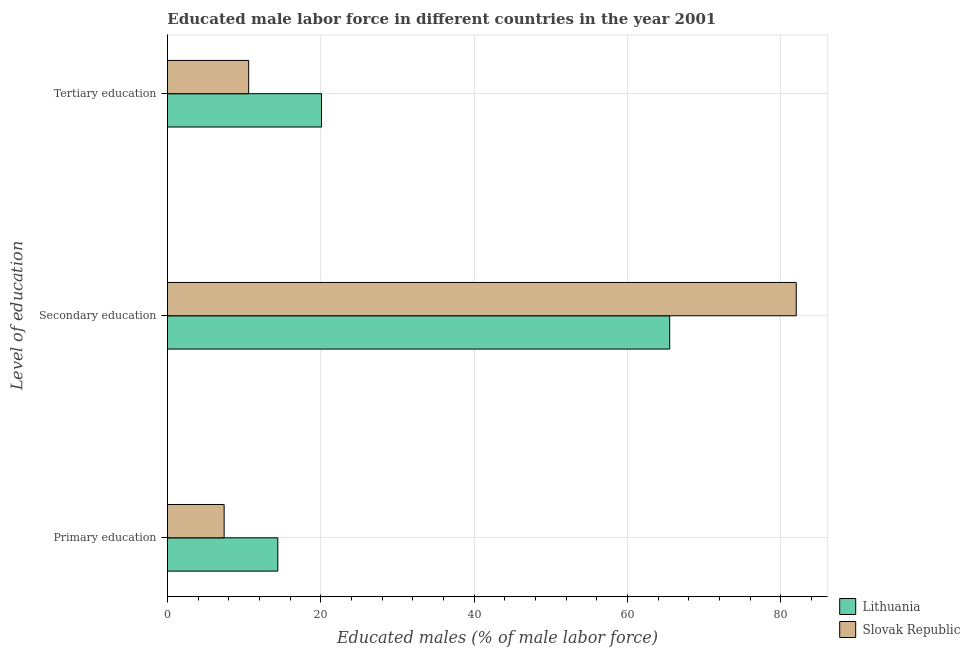How many groups of bars are there?
Make the answer very short. 3. Are the number of bars per tick equal to the number of legend labels?
Your response must be concise. Yes. Are the number of bars on each tick of the Y-axis equal?
Ensure brevity in your answer.  Yes. How many bars are there on the 2nd tick from the top?
Your answer should be compact. 2. What is the label of the 2nd group of bars from the top?
Ensure brevity in your answer.  Secondary education. What is the percentage of male labor force who received tertiary education in Slovak Republic?
Give a very brief answer. 10.6. Across all countries, what is the minimum percentage of male labor force who received primary education?
Your response must be concise. 7.4. In which country was the percentage of male labor force who received secondary education maximum?
Your answer should be very brief. Slovak Republic. In which country was the percentage of male labor force who received secondary education minimum?
Offer a terse response. Lithuania. What is the total percentage of male labor force who received secondary education in the graph?
Your answer should be very brief. 147.5. What is the difference between the percentage of male labor force who received tertiary education in Slovak Republic and that in Lithuania?
Offer a terse response. -9.5. What is the difference between the percentage of male labor force who received tertiary education in Slovak Republic and the percentage of male labor force who received primary education in Lithuania?
Provide a short and direct response. -3.8. What is the average percentage of male labor force who received tertiary education per country?
Offer a very short reply. 15.35. What is the difference between the percentage of male labor force who received tertiary education and percentage of male labor force who received primary education in Lithuania?
Give a very brief answer. 5.7. In how many countries, is the percentage of male labor force who received primary education greater than 24 %?
Make the answer very short. 0. What is the ratio of the percentage of male labor force who received secondary education in Slovak Republic to that in Lithuania?
Your answer should be very brief. 1.25. What is the difference between the highest and the second highest percentage of male labor force who received secondary education?
Offer a terse response. 16.5. Is the sum of the percentage of male labor force who received tertiary education in Lithuania and Slovak Republic greater than the maximum percentage of male labor force who received primary education across all countries?
Your answer should be compact. Yes. What does the 2nd bar from the top in Tertiary education represents?
Give a very brief answer. Lithuania. What does the 1st bar from the bottom in Tertiary education represents?
Offer a very short reply. Lithuania. How many bars are there?
Provide a short and direct response. 6. What is the difference between two consecutive major ticks on the X-axis?
Your response must be concise. 20. Does the graph contain grids?
Offer a very short reply. Yes. Where does the legend appear in the graph?
Provide a short and direct response. Bottom right. What is the title of the graph?
Keep it short and to the point. Educated male labor force in different countries in the year 2001. Does "Latin America(all income levels)" appear as one of the legend labels in the graph?
Your answer should be very brief. No. What is the label or title of the X-axis?
Offer a terse response. Educated males (% of male labor force). What is the label or title of the Y-axis?
Offer a very short reply. Level of education. What is the Educated males (% of male labor force) in Lithuania in Primary education?
Ensure brevity in your answer.  14.4. What is the Educated males (% of male labor force) in Slovak Republic in Primary education?
Provide a short and direct response. 7.4. What is the Educated males (% of male labor force) in Lithuania in Secondary education?
Ensure brevity in your answer.  65.5. What is the Educated males (% of male labor force) of Lithuania in Tertiary education?
Provide a short and direct response. 20.1. What is the Educated males (% of male labor force) of Slovak Republic in Tertiary education?
Provide a succinct answer. 10.6. Across all Level of education, what is the maximum Educated males (% of male labor force) in Lithuania?
Provide a succinct answer. 65.5. Across all Level of education, what is the maximum Educated males (% of male labor force) of Slovak Republic?
Offer a very short reply. 82. Across all Level of education, what is the minimum Educated males (% of male labor force) of Lithuania?
Offer a very short reply. 14.4. Across all Level of education, what is the minimum Educated males (% of male labor force) of Slovak Republic?
Your answer should be very brief. 7.4. What is the difference between the Educated males (% of male labor force) of Lithuania in Primary education and that in Secondary education?
Offer a very short reply. -51.1. What is the difference between the Educated males (% of male labor force) in Slovak Republic in Primary education and that in Secondary education?
Keep it short and to the point. -74.6. What is the difference between the Educated males (% of male labor force) in Lithuania in Secondary education and that in Tertiary education?
Keep it short and to the point. 45.4. What is the difference between the Educated males (% of male labor force) of Slovak Republic in Secondary education and that in Tertiary education?
Offer a terse response. 71.4. What is the difference between the Educated males (% of male labor force) in Lithuania in Primary education and the Educated males (% of male labor force) in Slovak Republic in Secondary education?
Provide a short and direct response. -67.6. What is the difference between the Educated males (% of male labor force) of Lithuania in Secondary education and the Educated males (% of male labor force) of Slovak Republic in Tertiary education?
Your answer should be very brief. 54.9. What is the average Educated males (% of male labor force) in Lithuania per Level of education?
Keep it short and to the point. 33.33. What is the average Educated males (% of male labor force) of Slovak Republic per Level of education?
Make the answer very short. 33.33. What is the difference between the Educated males (% of male labor force) in Lithuania and Educated males (% of male labor force) in Slovak Republic in Primary education?
Your answer should be compact. 7. What is the difference between the Educated males (% of male labor force) in Lithuania and Educated males (% of male labor force) in Slovak Republic in Secondary education?
Your answer should be very brief. -16.5. What is the difference between the Educated males (% of male labor force) of Lithuania and Educated males (% of male labor force) of Slovak Republic in Tertiary education?
Provide a short and direct response. 9.5. What is the ratio of the Educated males (% of male labor force) of Lithuania in Primary education to that in Secondary education?
Provide a short and direct response. 0.22. What is the ratio of the Educated males (% of male labor force) of Slovak Republic in Primary education to that in Secondary education?
Your response must be concise. 0.09. What is the ratio of the Educated males (% of male labor force) in Lithuania in Primary education to that in Tertiary education?
Provide a succinct answer. 0.72. What is the ratio of the Educated males (% of male labor force) of Slovak Republic in Primary education to that in Tertiary education?
Offer a very short reply. 0.7. What is the ratio of the Educated males (% of male labor force) in Lithuania in Secondary education to that in Tertiary education?
Keep it short and to the point. 3.26. What is the ratio of the Educated males (% of male labor force) in Slovak Republic in Secondary education to that in Tertiary education?
Keep it short and to the point. 7.74. What is the difference between the highest and the second highest Educated males (% of male labor force) in Lithuania?
Your answer should be compact. 45.4. What is the difference between the highest and the second highest Educated males (% of male labor force) in Slovak Republic?
Provide a succinct answer. 71.4. What is the difference between the highest and the lowest Educated males (% of male labor force) in Lithuania?
Offer a terse response. 51.1. What is the difference between the highest and the lowest Educated males (% of male labor force) of Slovak Republic?
Make the answer very short. 74.6. 